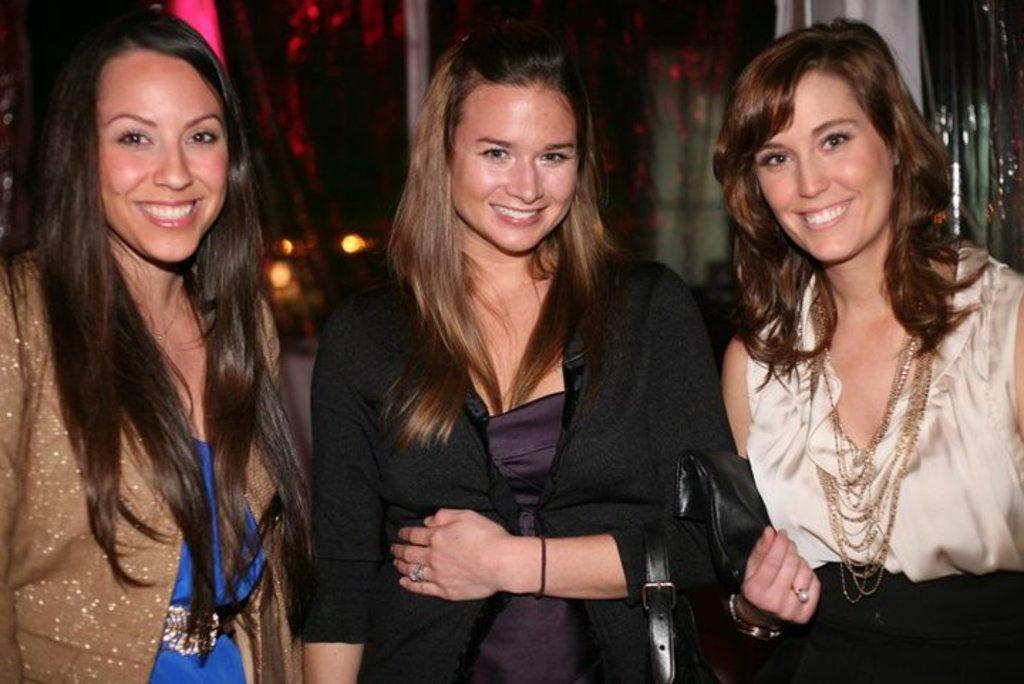How many people are in the image? There are three persons in the image. What are the persons doing in the image? The persons are standing and smiling. What can be seen in the background of the image? There is a curtain in the background of the image. What type of organization is responsible for the night in the image? There is no mention of night or any organization in the image. The image features three persons standing and smiling, with a curtain in the background. 